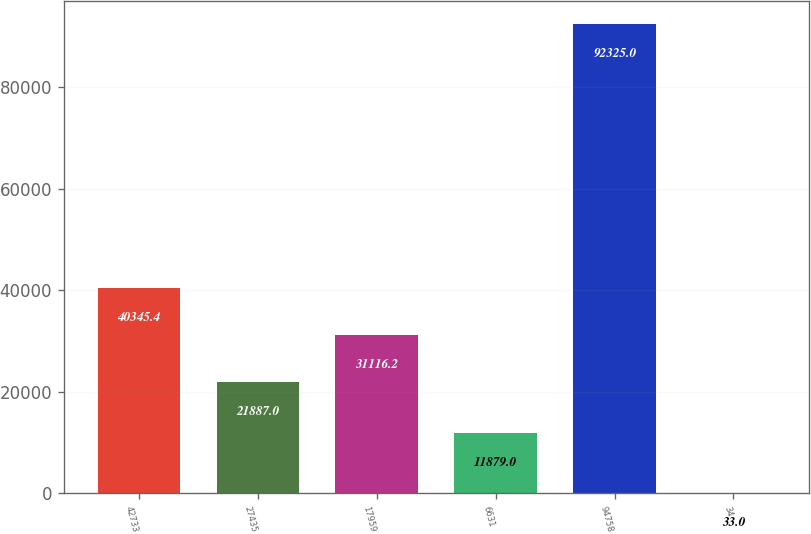Convert chart. <chart><loc_0><loc_0><loc_500><loc_500><bar_chart><fcel>42733<fcel>27435<fcel>17959<fcel>6631<fcel>94758<fcel>34<nl><fcel>40345.4<fcel>21887<fcel>31116.2<fcel>11879<fcel>92325<fcel>33<nl></chart> 